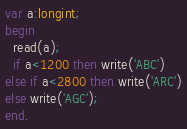<code> <loc_0><loc_0><loc_500><loc_500><_Pascal_>var a:longint;
begin 
  read(a);
  if a<1200 then write('ABC')
else if a<2800 then write('ARC')
else write('AGC');
end.</code> 